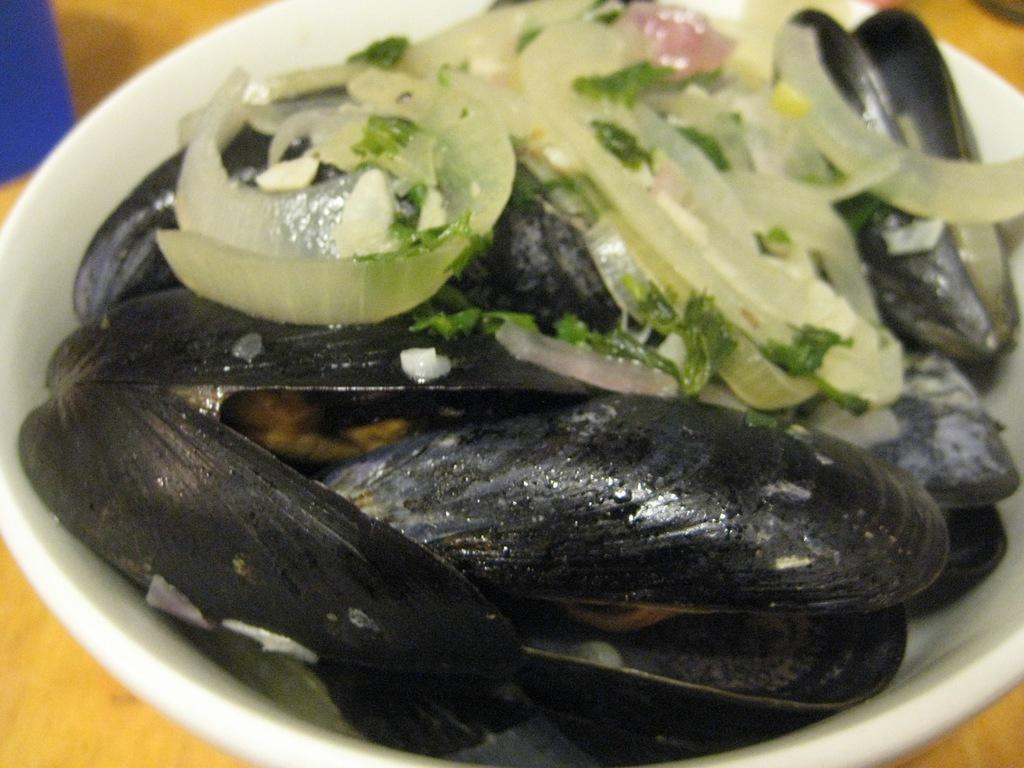What is in the bowl that is visible in the image? There is a bowl containing food in the image. Where is the bowl located in the image? The bowl is placed on a table. What type of eggnog can be seen in the image? There is no eggnog present in the image; it only contains food in a bowl. What channel is the sneeze being broadcasted on in the image? There is no sneeze or broadcasting present in the image. 